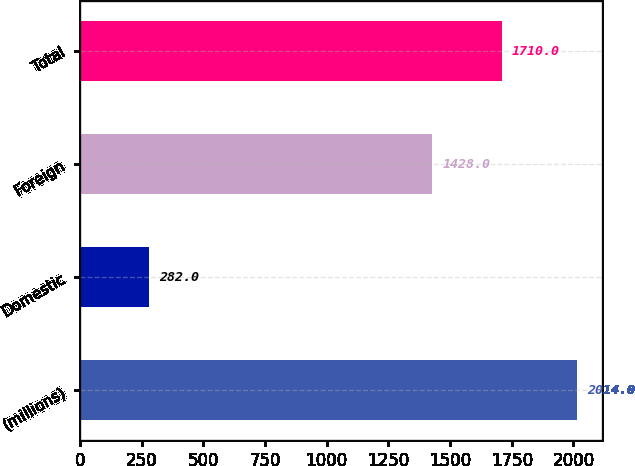Convert chart to OTSL. <chart><loc_0><loc_0><loc_500><loc_500><bar_chart><fcel>(millions)<fcel>Domestic<fcel>Foreign<fcel>Total<nl><fcel>2014<fcel>282<fcel>1428<fcel>1710<nl></chart> 